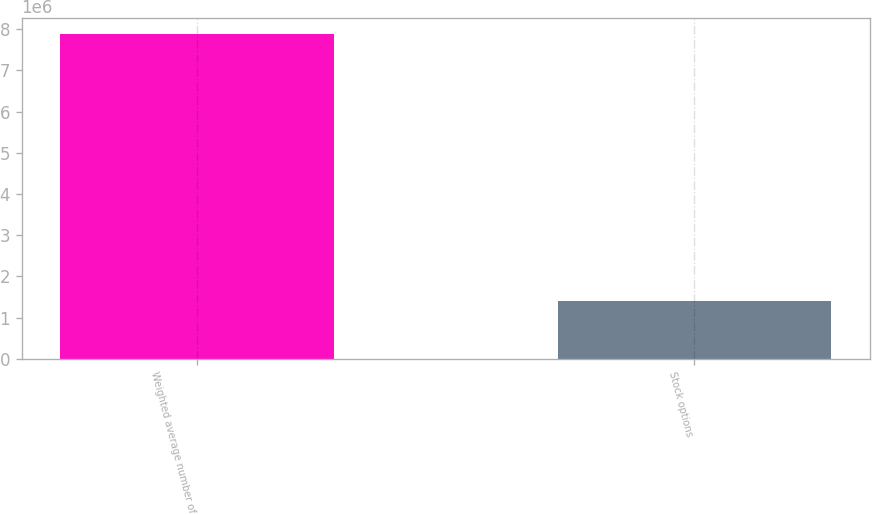Convert chart to OTSL. <chart><loc_0><loc_0><loc_500><loc_500><bar_chart><fcel>Weighted average number of<fcel>Stock options<nl><fcel>7.87687e+06<fcel>1.40426e+06<nl></chart> 